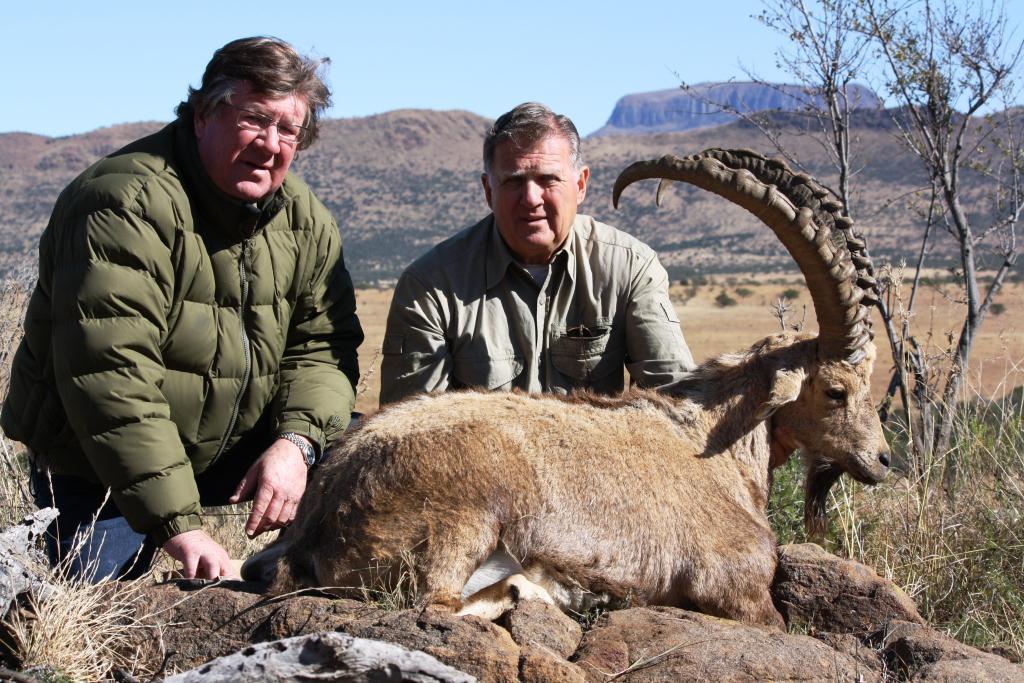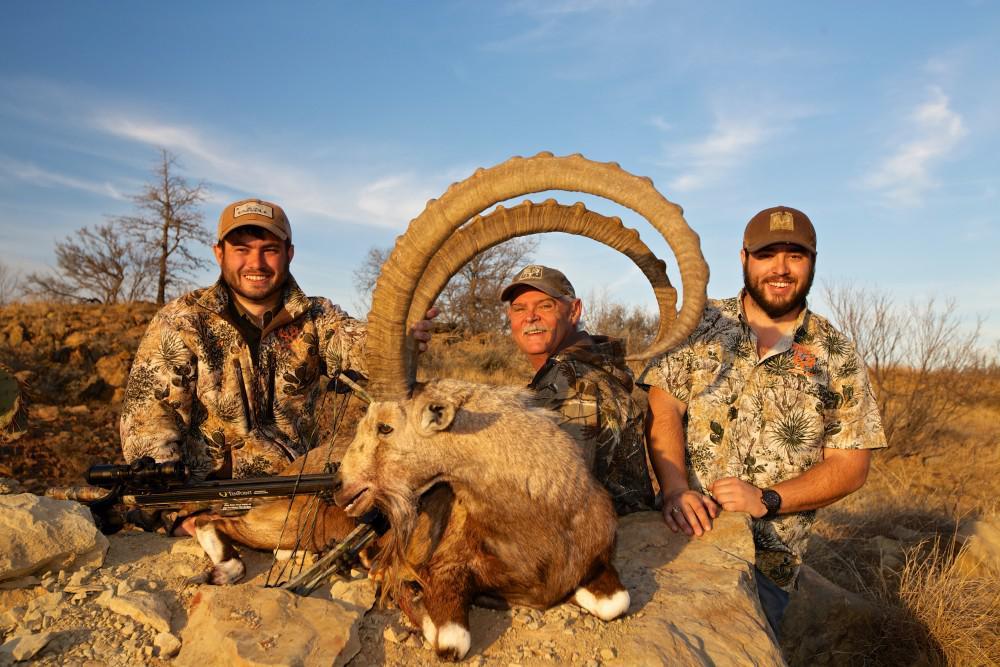The first image is the image on the left, the second image is the image on the right. Given the left and right images, does the statement "An image shows one man in a hat behind a downed animal, holding onto the tip of one horn with his hand." hold true? Answer yes or no. No. 